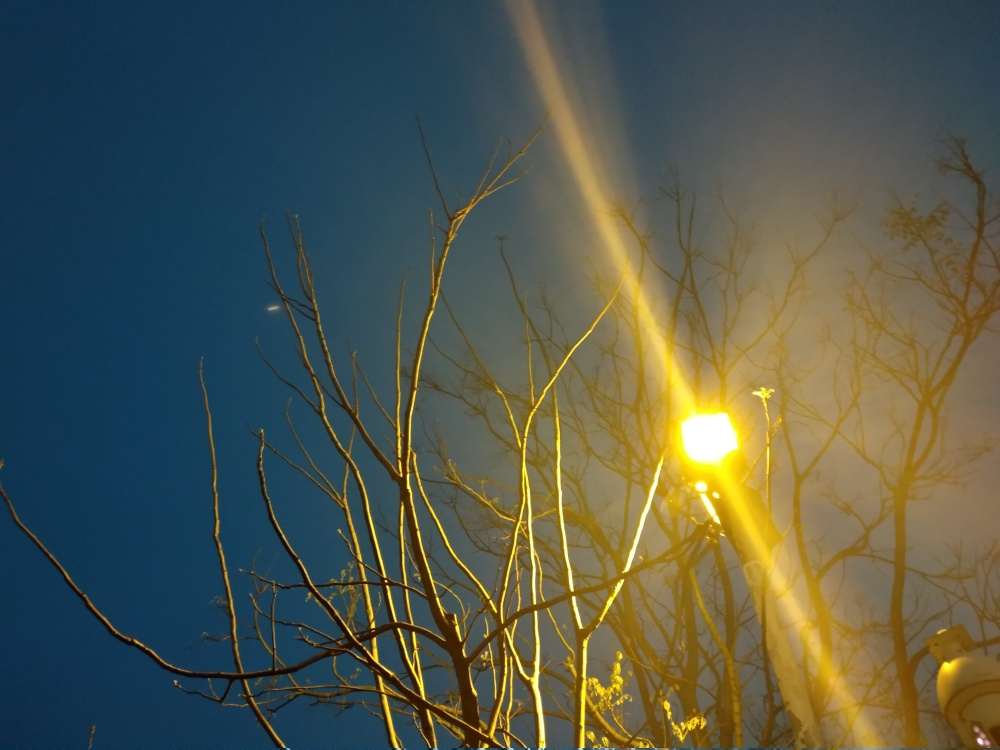Can you tell me about the composition and how it affects the image? The composition uses the rule of thirds to position the light, which creates a dynamic balance. The ray of light leads the eye diagonally across the image. However, the overexposed light can draw the viewer's attention away from the subtler details of the branches and the night sky. What adjustments could improve this photo's composition? To improve this composition, the photographer could adjust the angle to avoid direct light into the lens, which would reveal more details of the tree and the evening sky. Additionally, capturing the image during the 'blue hour' could provide more balanced lighting and color saturation. 